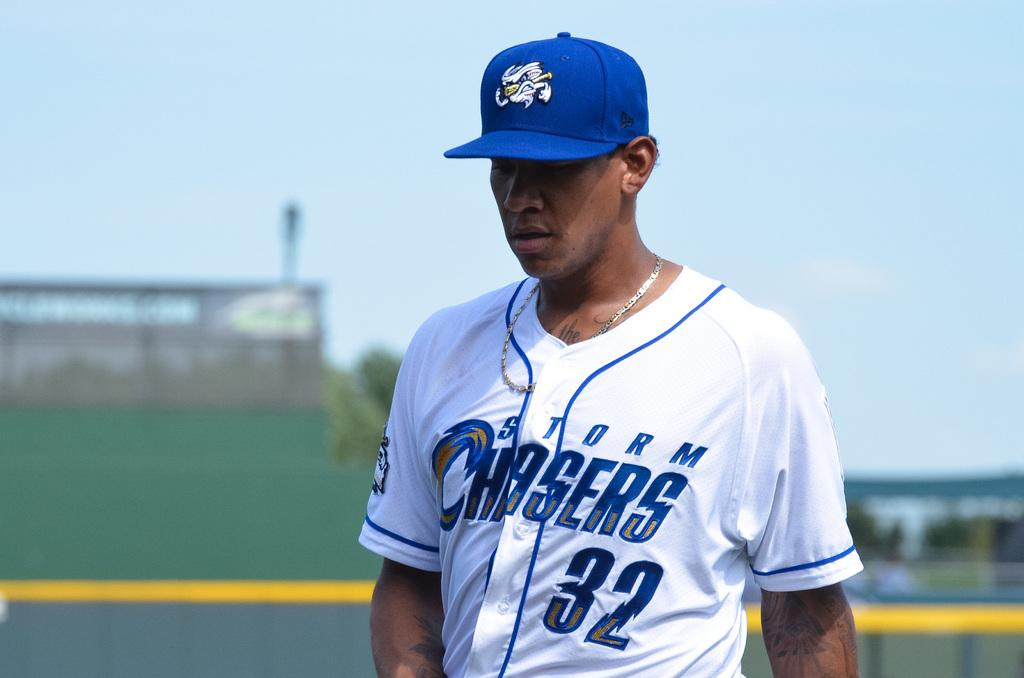Provide a one-sentence caption for the provided image. A baseball player is wearing a Storm Chasers 32 jersey. 